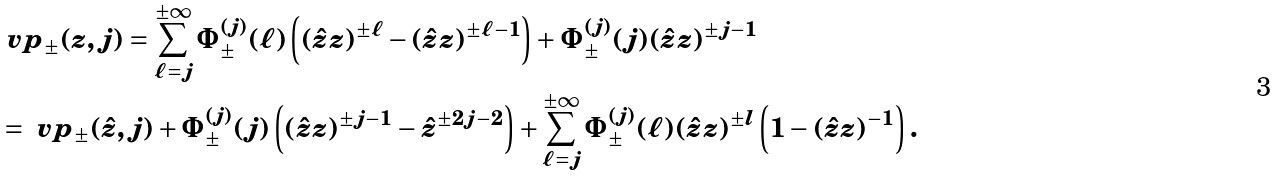Convert formula to latex. <formula><loc_0><loc_0><loc_500><loc_500>& \ v p _ { \pm } ( z , j ) = \sum _ { \ell = j } ^ { \pm \infty } \Phi _ { \pm } ^ { ( j ) } ( \ell ) \left ( ( \hat { z } z ) ^ { \pm \ell } - ( \hat { z } z ) ^ { \pm \ell - 1 } \right ) + \Phi _ { \pm } ^ { ( j ) } ( j ) ( \hat { z } z ) ^ { \pm j - 1 } \\ & = \ v p _ { \pm } ( \hat { z } , j ) + \Phi _ { \pm } ^ { ( j ) } ( j ) \left ( ( \hat { z } z ) ^ { \pm j - 1 } - \hat { z } ^ { \pm 2 j - 2 } \right ) + \sum _ { \ell = j } ^ { \pm \infty } \Phi _ { \pm } ^ { ( j ) } ( \ell ) ( \hat { z } z ) ^ { \pm l } \left ( 1 - ( \hat { z } z ) ^ { - 1 } \right ) .</formula> 